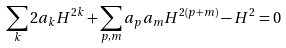Convert formula to latex. <formula><loc_0><loc_0><loc_500><loc_500>\sum _ { k } 2 a _ { k } H ^ { 2 k } + \sum _ { p , m } a _ { p } a _ { m } H ^ { 2 ( p + m ) } - H ^ { 2 } = 0</formula> 